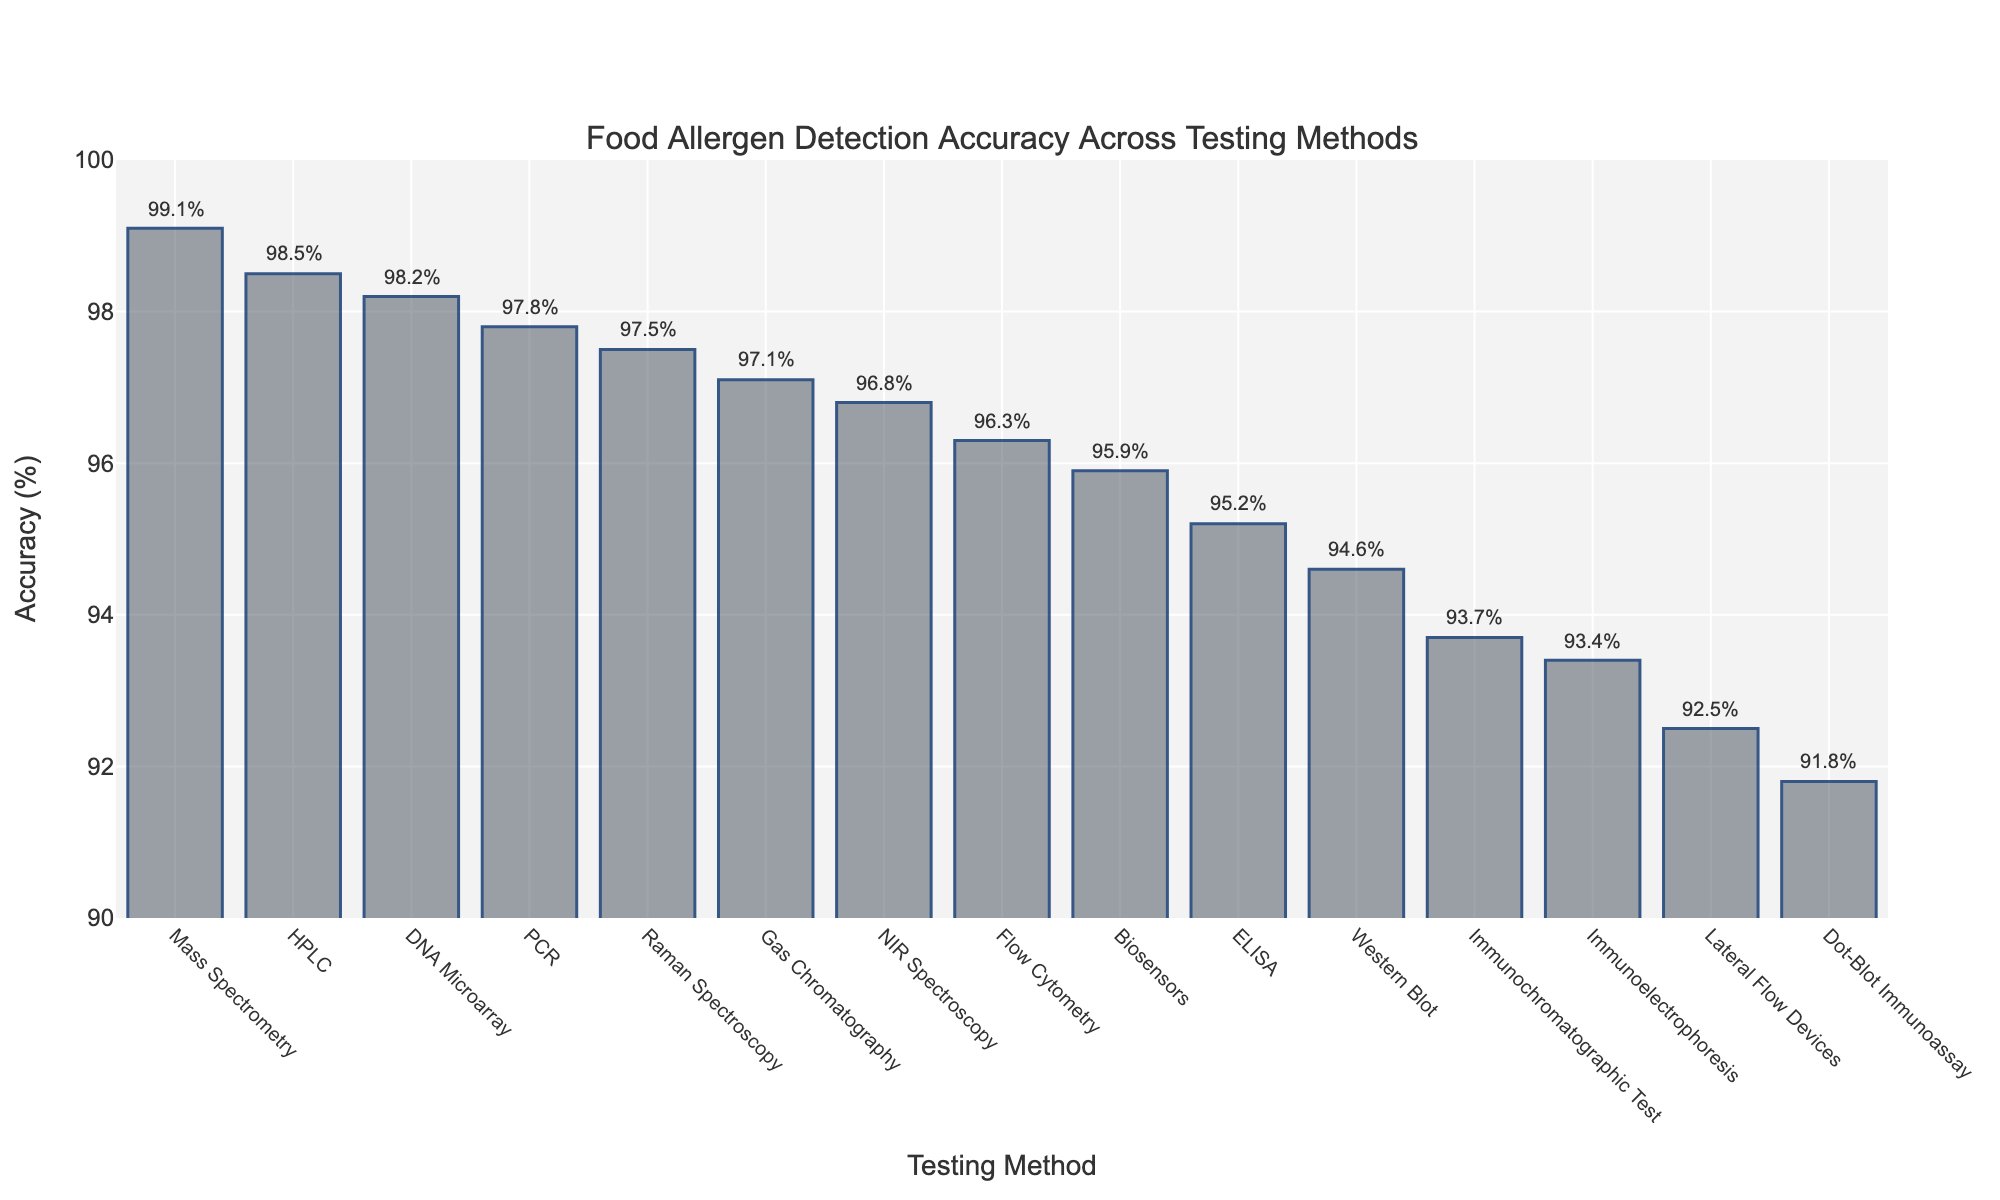Which testing method has the highest accuracy? By observing the height of the bars, it's clear that Mass Spectrometry has the highest bar, representing the highest accuracy at 99.1%.
Answer: Mass Spectrometry Which testing method has the lowest accuracy? By looking at the shortest bar, Dot-Blot Immunoassay has the lowest accuracy at 91.8%.
Answer: Dot-Blot Immunoassay What is the accuracy range of all the testing methods? The highest accuracy is 99.1% (Mass Spectrometry), and the lowest is 91.8% (Dot-Blot Immunoassay). So, the accuracy range is 99.1% - 91.8% = 7.3%.
Answer: 7.3% How many testing methods have an accuracy above 97%? By counting the bars representing accuracies above 97%, the methods are PCR, Mass Spectrometry, DNA Microarray, HPLC, and Raman Spectroscopy. There are 5 such methods.
Answer: 5 Which testing method has an accuracy closest to 95%? By observing the heights near 95% and checking the annotations, ELISA has an accuracy of 95.2%, which is closest to 95%.
Answer: ELISA What is the average accuracy of ELISA, PCR, and Mass Spectrometry? Summing the accuracies: 95.2% + 97.8% + 99.1% = 292.1%. The average is 292.1% / 3 = 97.37%.
Answer: 97.37% How does the accuracy of ELISA compare to Western Blot? ELISA has an accuracy of 95.2%, while Western Blot has 94.6%. So, ELISA's accuracy is higher.
Answer: ELISA > Western Blot What is the median accuracy of all testing methods? By sorting the accuracies, the values are: 91.8, 92.5, 93.4, 93.7, 94.6, 95.2, 95.9, 96.3, 96.8, 97.1, 97.5, 97.8, 98.2, 98.5, 99.1. The median is the middle value, which is 96.3%.
Answer: 96.3% Which two methods have the closest accuracy to each other? By comparing differences, Flow Cytometry (96.3%) and NIR Spectroscopy (96.8%) have the closest accuracies, differing by only 0.5%.
Answer: Flow Cytometry and NIR Spectroscopy 